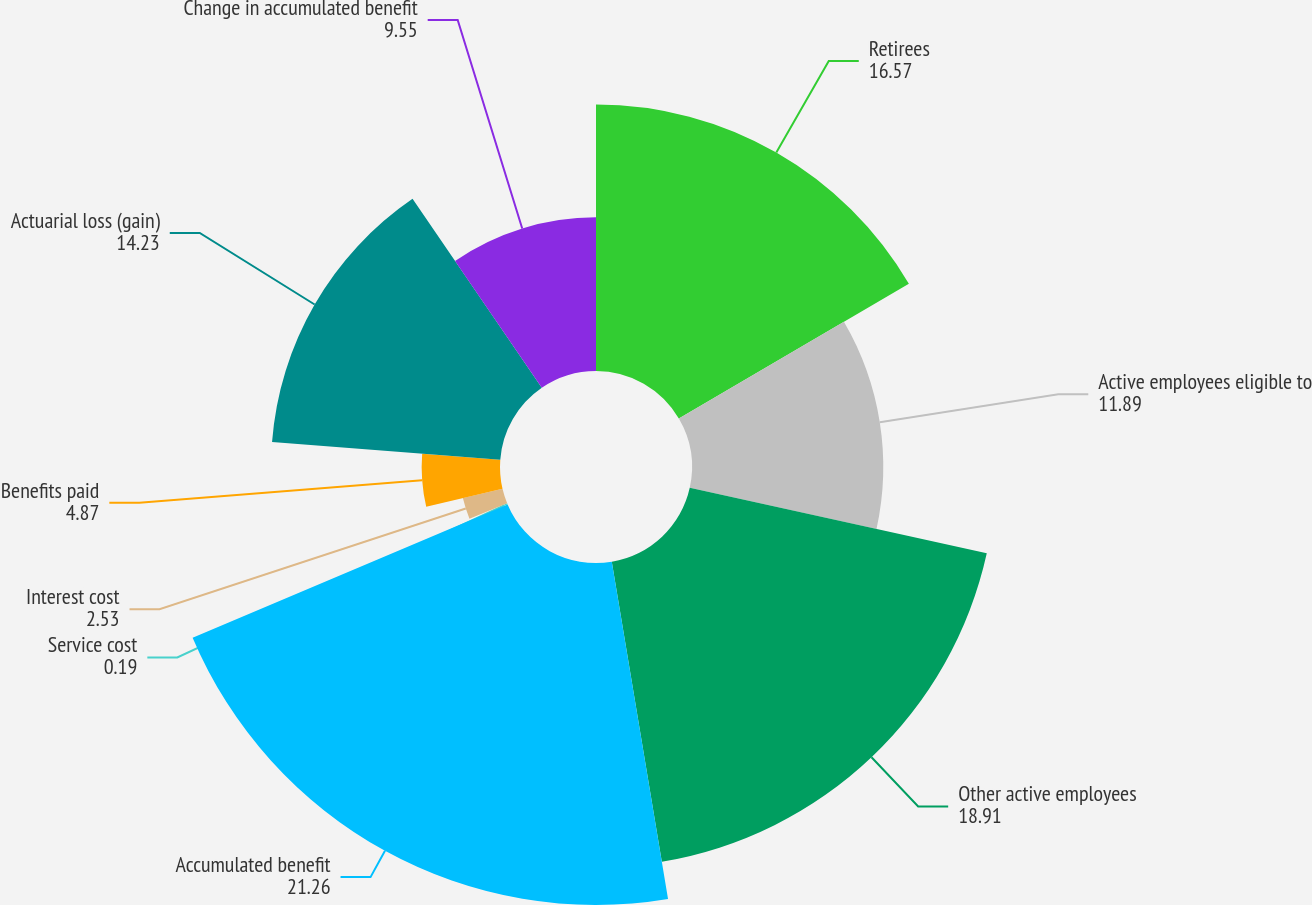<chart> <loc_0><loc_0><loc_500><loc_500><pie_chart><fcel>Retirees<fcel>Active employees eligible to<fcel>Other active employees<fcel>Accumulated benefit<fcel>Service cost<fcel>Interest cost<fcel>Benefits paid<fcel>Actuarial loss (gain)<fcel>Change in accumulated benefit<nl><fcel>16.57%<fcel>11.89%<fcel>18.91%<fcel>21.26%<fcel>0.19%<fcel>2.53%<fcel>4.87%<fcel>14.23%<fcel>9.55%<nl></chart> 